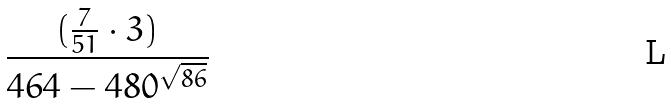Convert formula to latex. <formula><loc_0><loc_0><loc_500><loc_500>\frac { ( \frac { 7 } { 5 1 } \cdot 3 ) } { 4 6 4 - 4 8 0 ^ { \sqrt { 8 6 } } }</formula> 